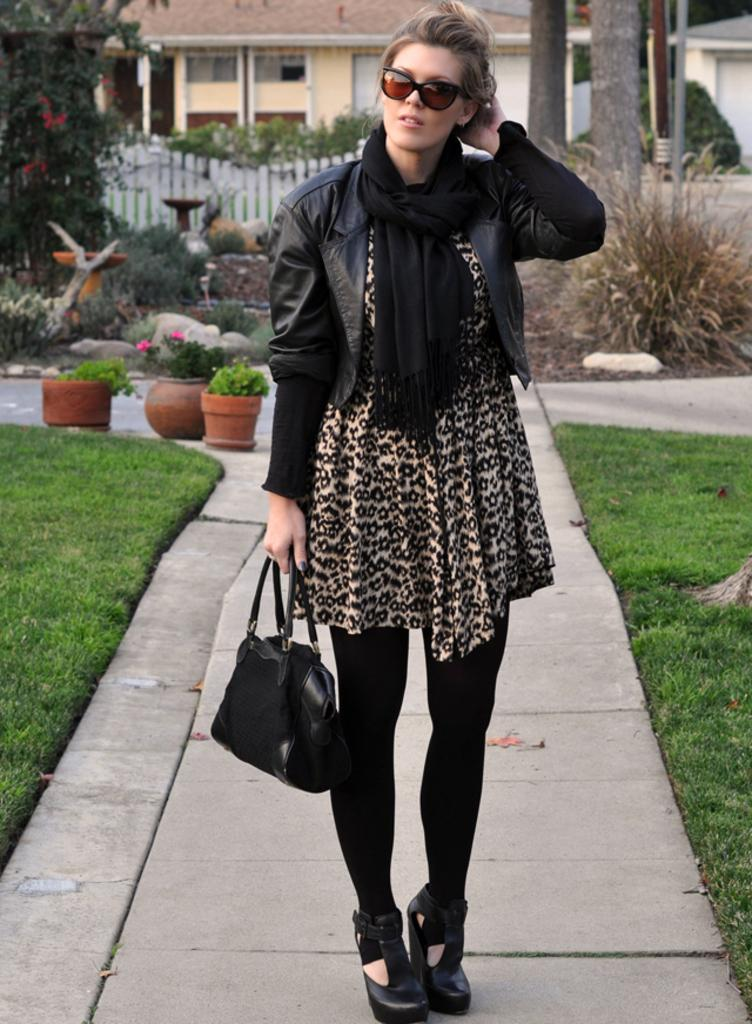Who is present in the image? There is a woman in the image. What is the woman doing in the image? The woman is standing. What is the woman holding in the image? The woman is carrying a black color bag in her hand. What type of bread can be seen in the woman's hand in the image? There is no bread present in the image; the woman is carrying a black color bag in her hand. 